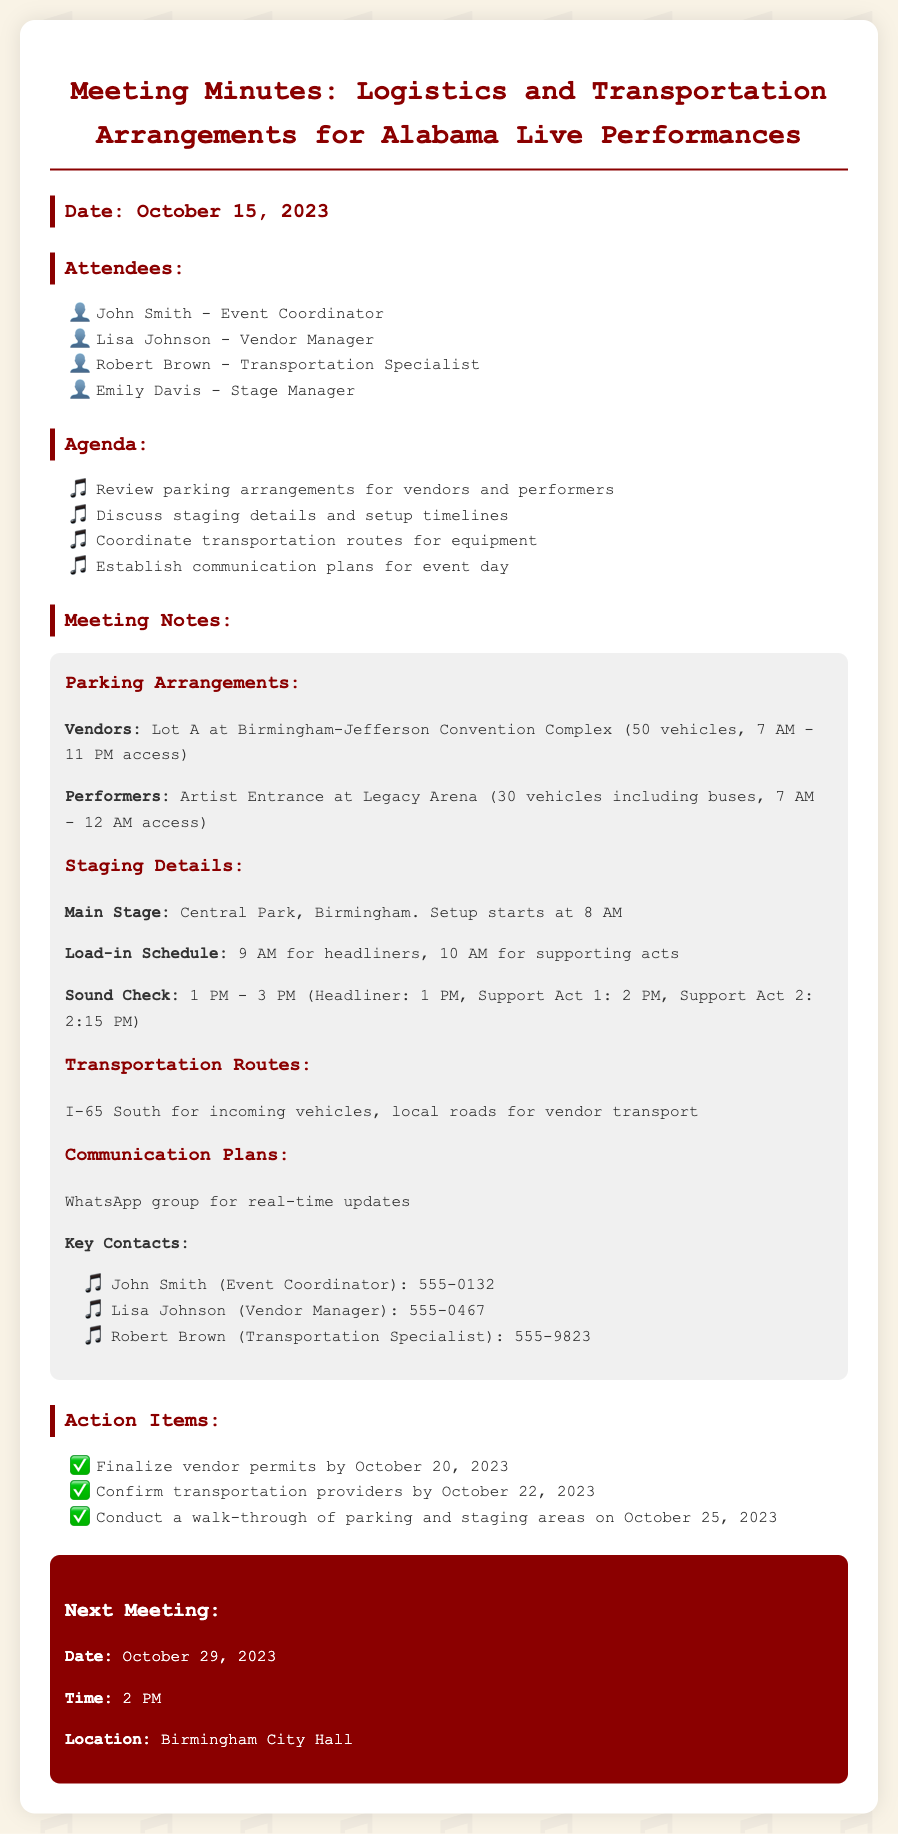what is the date of the meeting? The meeting was held on October 15, 2023.
Answer: October 15, 2023 who is the Event Coordinator? The Event Coordinator mentioned is John Smith.
Answer: John Smith how many vehicles can park in Lot A? Lot A can accommodate 50 vehicles for vendors.
Answer: 50 vehicles when does the load-in schedule start for headliners? The load-in schedule for headliners begins at 9 AM.
Answer: 9 AM what communication tool will be used on event day? The communication tool designated for real-time updates is WhatsApp.
Answer: WhatsApp how many vehicles can park at the Artist Entrance? The Artist Entrance can accommodate 30 vehicles including buses.
Answer: 30 vehicles when is the next meeting scheduled? The next meeting is scheduled for October 29, 2023.
Answer: October 29, 2023 what is the purpose of the action items section? The action items outline specific tasks to be completed prior to the event.
Answer: Specific tasks who is responsible for confirming transportation providers? Confirming transportation providers is the responsibility of Lisa Johnson.
Answer: Lisa Johnson 